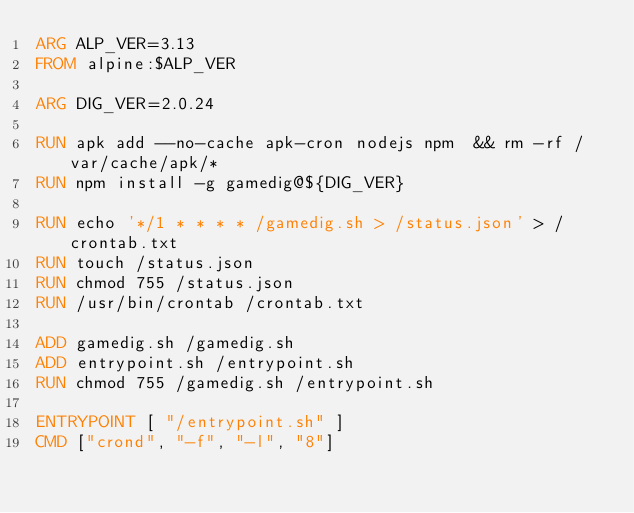Convert code to text. <code><loc_0><loc_0><loc_500><loc_500><_Dockerfile_>ARG ALP_VER=3.13
FROM alpine:$ALP_VER

ARG DIG_VER=2.0.24

RUN apk add --no-cache apk-cron nodejs npm  && rm -rf /var/cache/apk/*
RUN npm install -g gamedig@${DIG_VER}

RUN echo '*/1 * * * * /gamedig.sh > /status.json' > /crontab.txt
RUN touch /status.json
RUN chmod 755 /status.json
RUN /usr/bin/crontab /crontab.txt

ADD gamedig.sh /gamedig.sh
ADD entrypoint.sh /entrypoint.sh
RUN chmod 755 /gamedig.sh /entrypoint.sh

ENTRYPOINT [ "/entrypoint.sh" ]
CMD ["crond", "-f", "-l", "8"]
</code> 